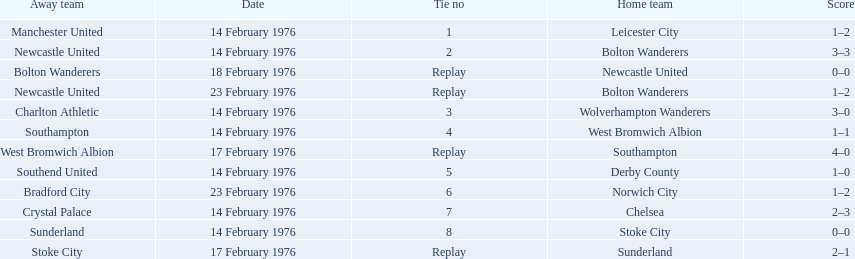What is the game at the top of the table? 1. Who is the home team for this game? Leicester City. 